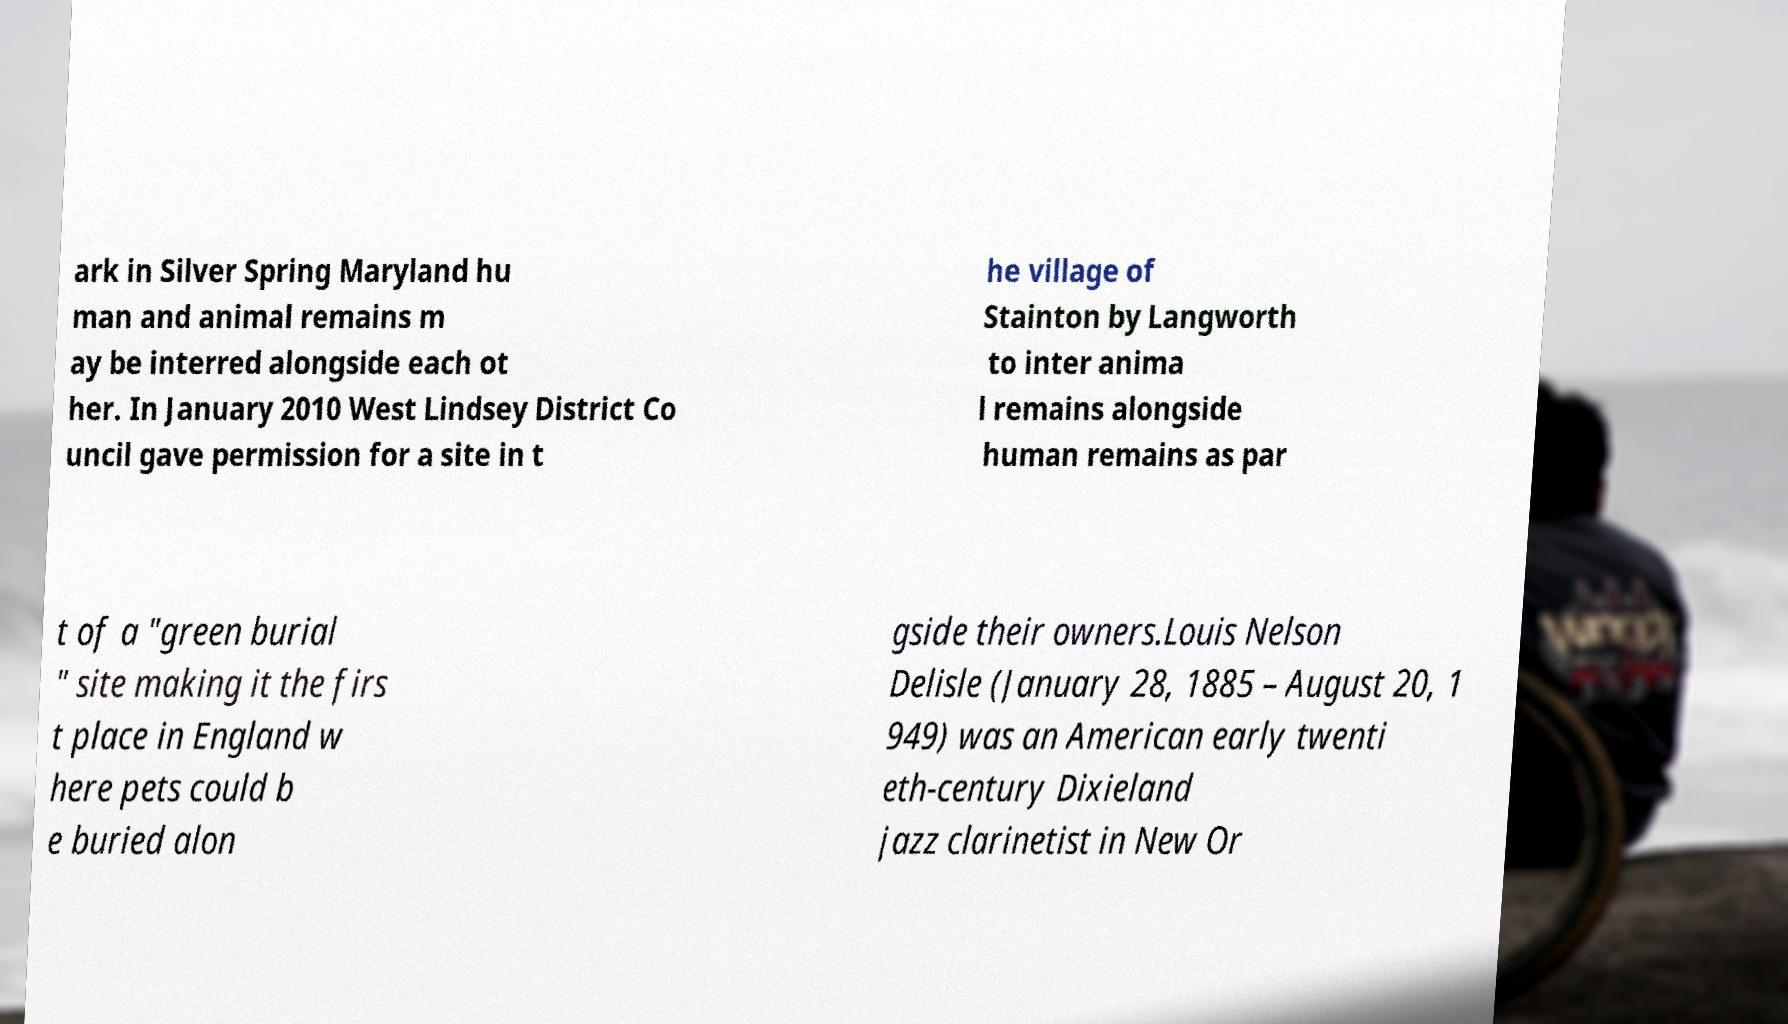I need the written content from this picture converted into text. Can you do that? ark in Silver Spring Maryland hu man and animal remains m ay be interred alongside each ot her. In January 2010 West Lindsey District Co uncil gave permission for a site in t he village of Stainton by Langworth to inter anima l remains alongside human remains as par t of a "green burial " site making it the firs t place in England w here pets could b e buried alon gside their owners.Louis Nelson Delisle (January 28, 1885 – August 20, 1 949) was an American early twenti eth-century Dixieland jazz clarinetist in New Or 